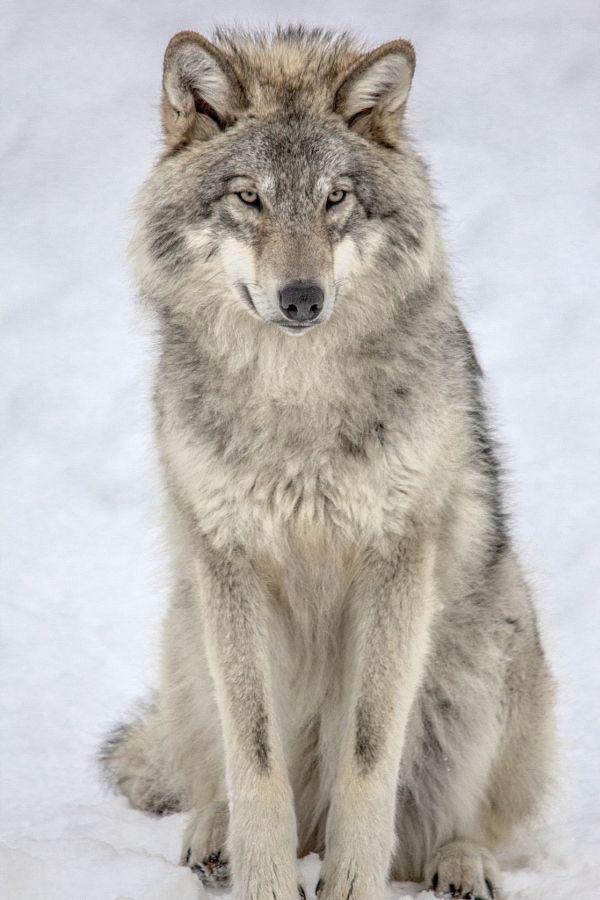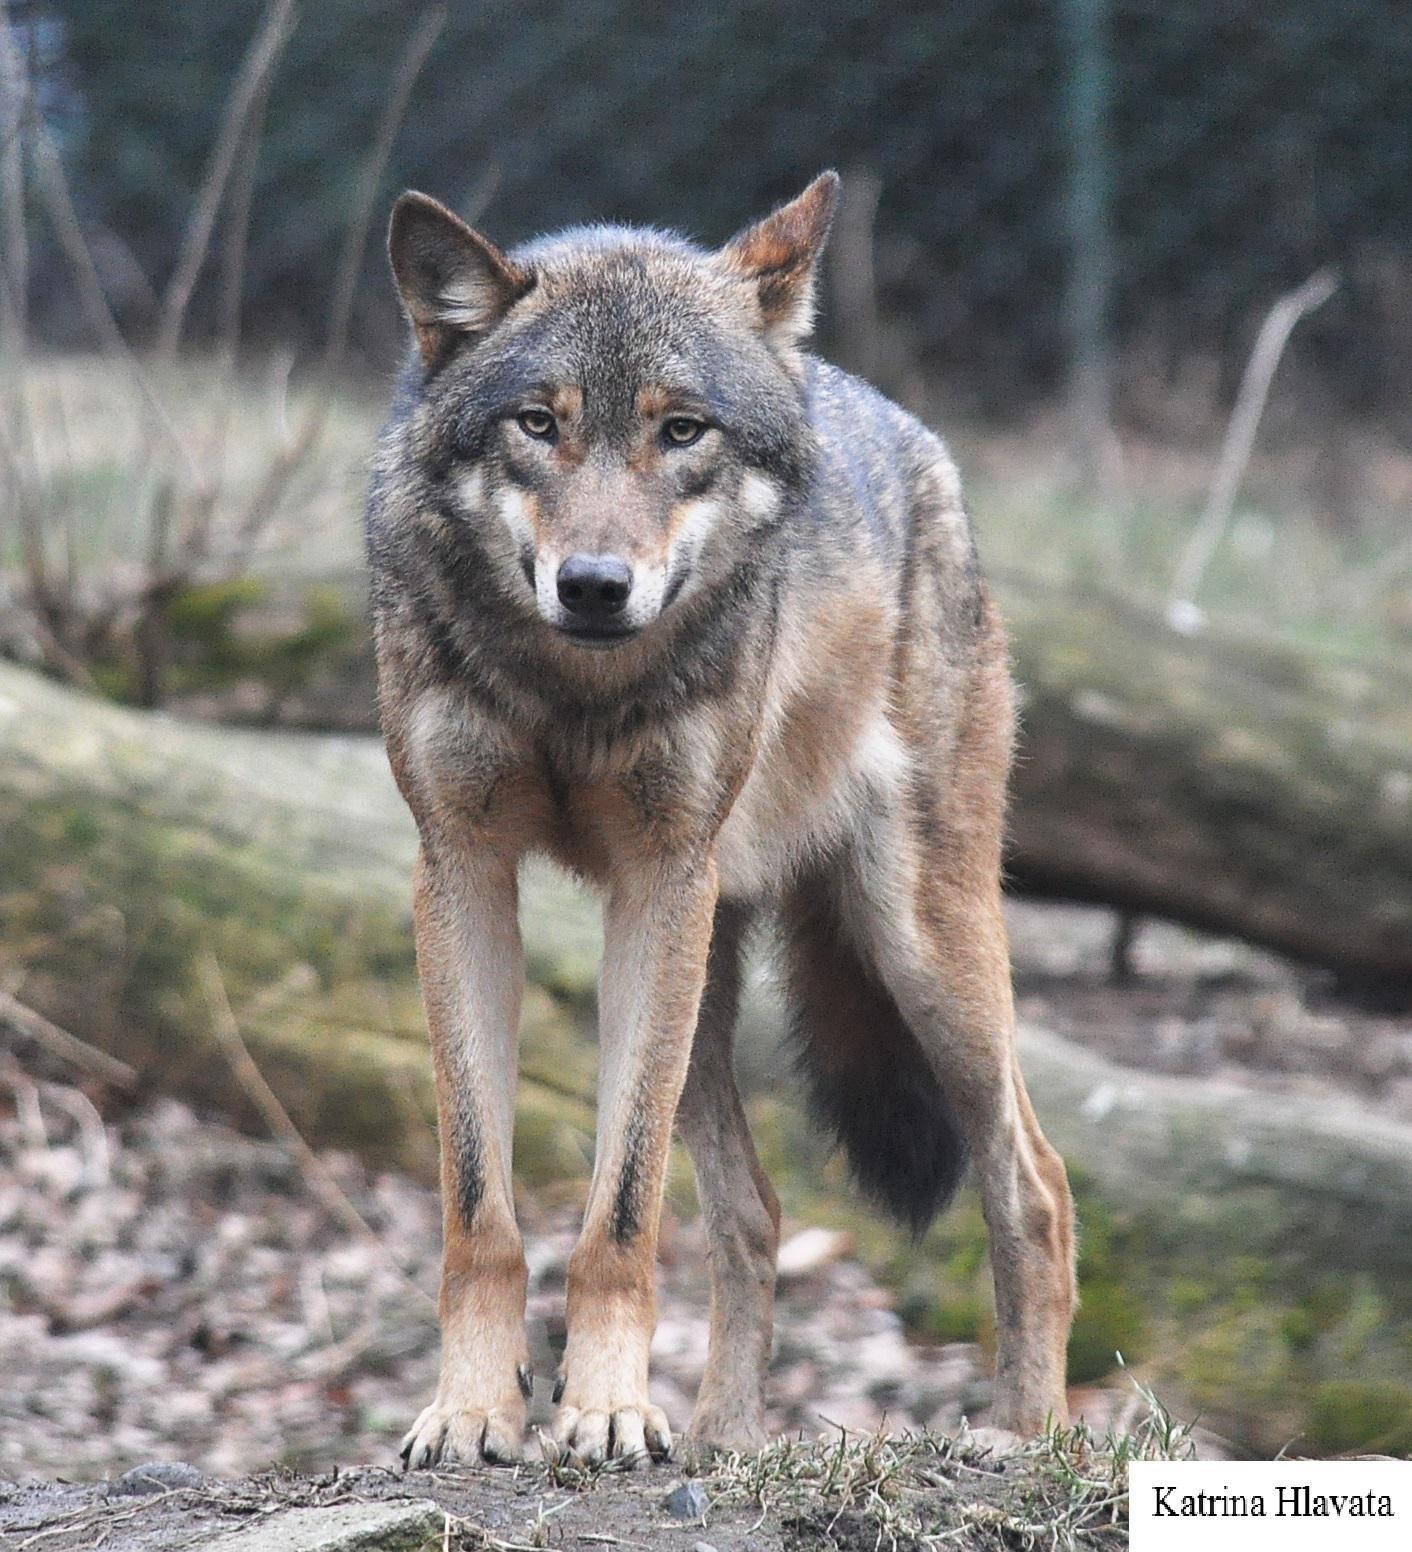The first image is the image on the left, the second image is the image on the right. Considering the images on both sides, is "The left image contains twice as many wolves as the right image." valid? Answer yes or no. No. The first image is the image on the left, the second image is the image on the right. For the images shown, is this caption "Three wolves are visible." true? Answer yes or no. No. 